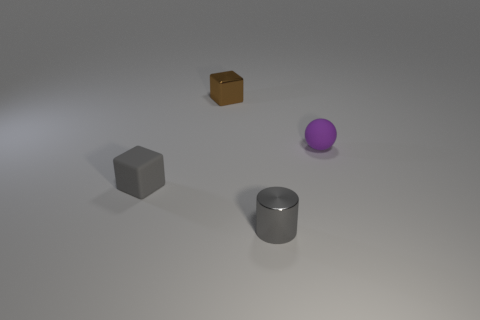Add 2 gray matte balls. How many objects exist? 6 Subtract all cylinders. How many objects are left? 3 Add 2 small metal things. How many small metal things exist? 4 Subtract 0 brown cylinders. How many objects are left? 4 Subtract all small gray cylinders. Subtract all tiny gray metallic objects. How many objects are left? 2 Add 2 small blocks. How many small blocks are left? 4 